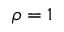<formula> <loc_0><loc_0><loc_500><loc_500>\rho = 1</formula> 